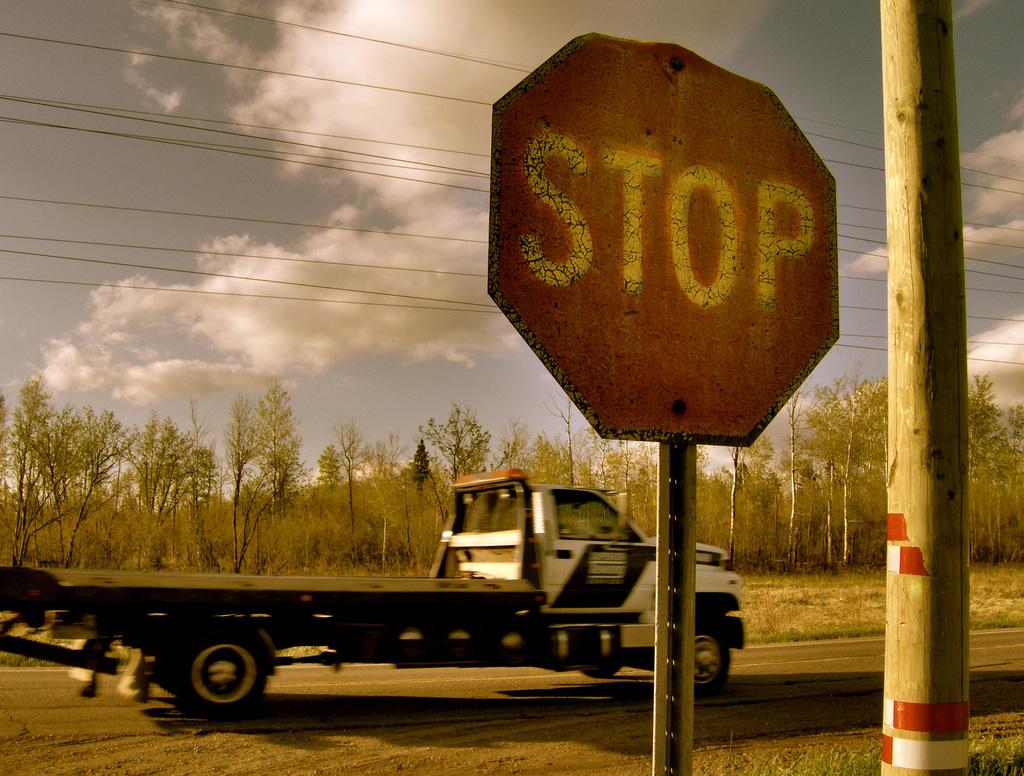What kind of road sign?
Provide a short and direct response. Stop. 